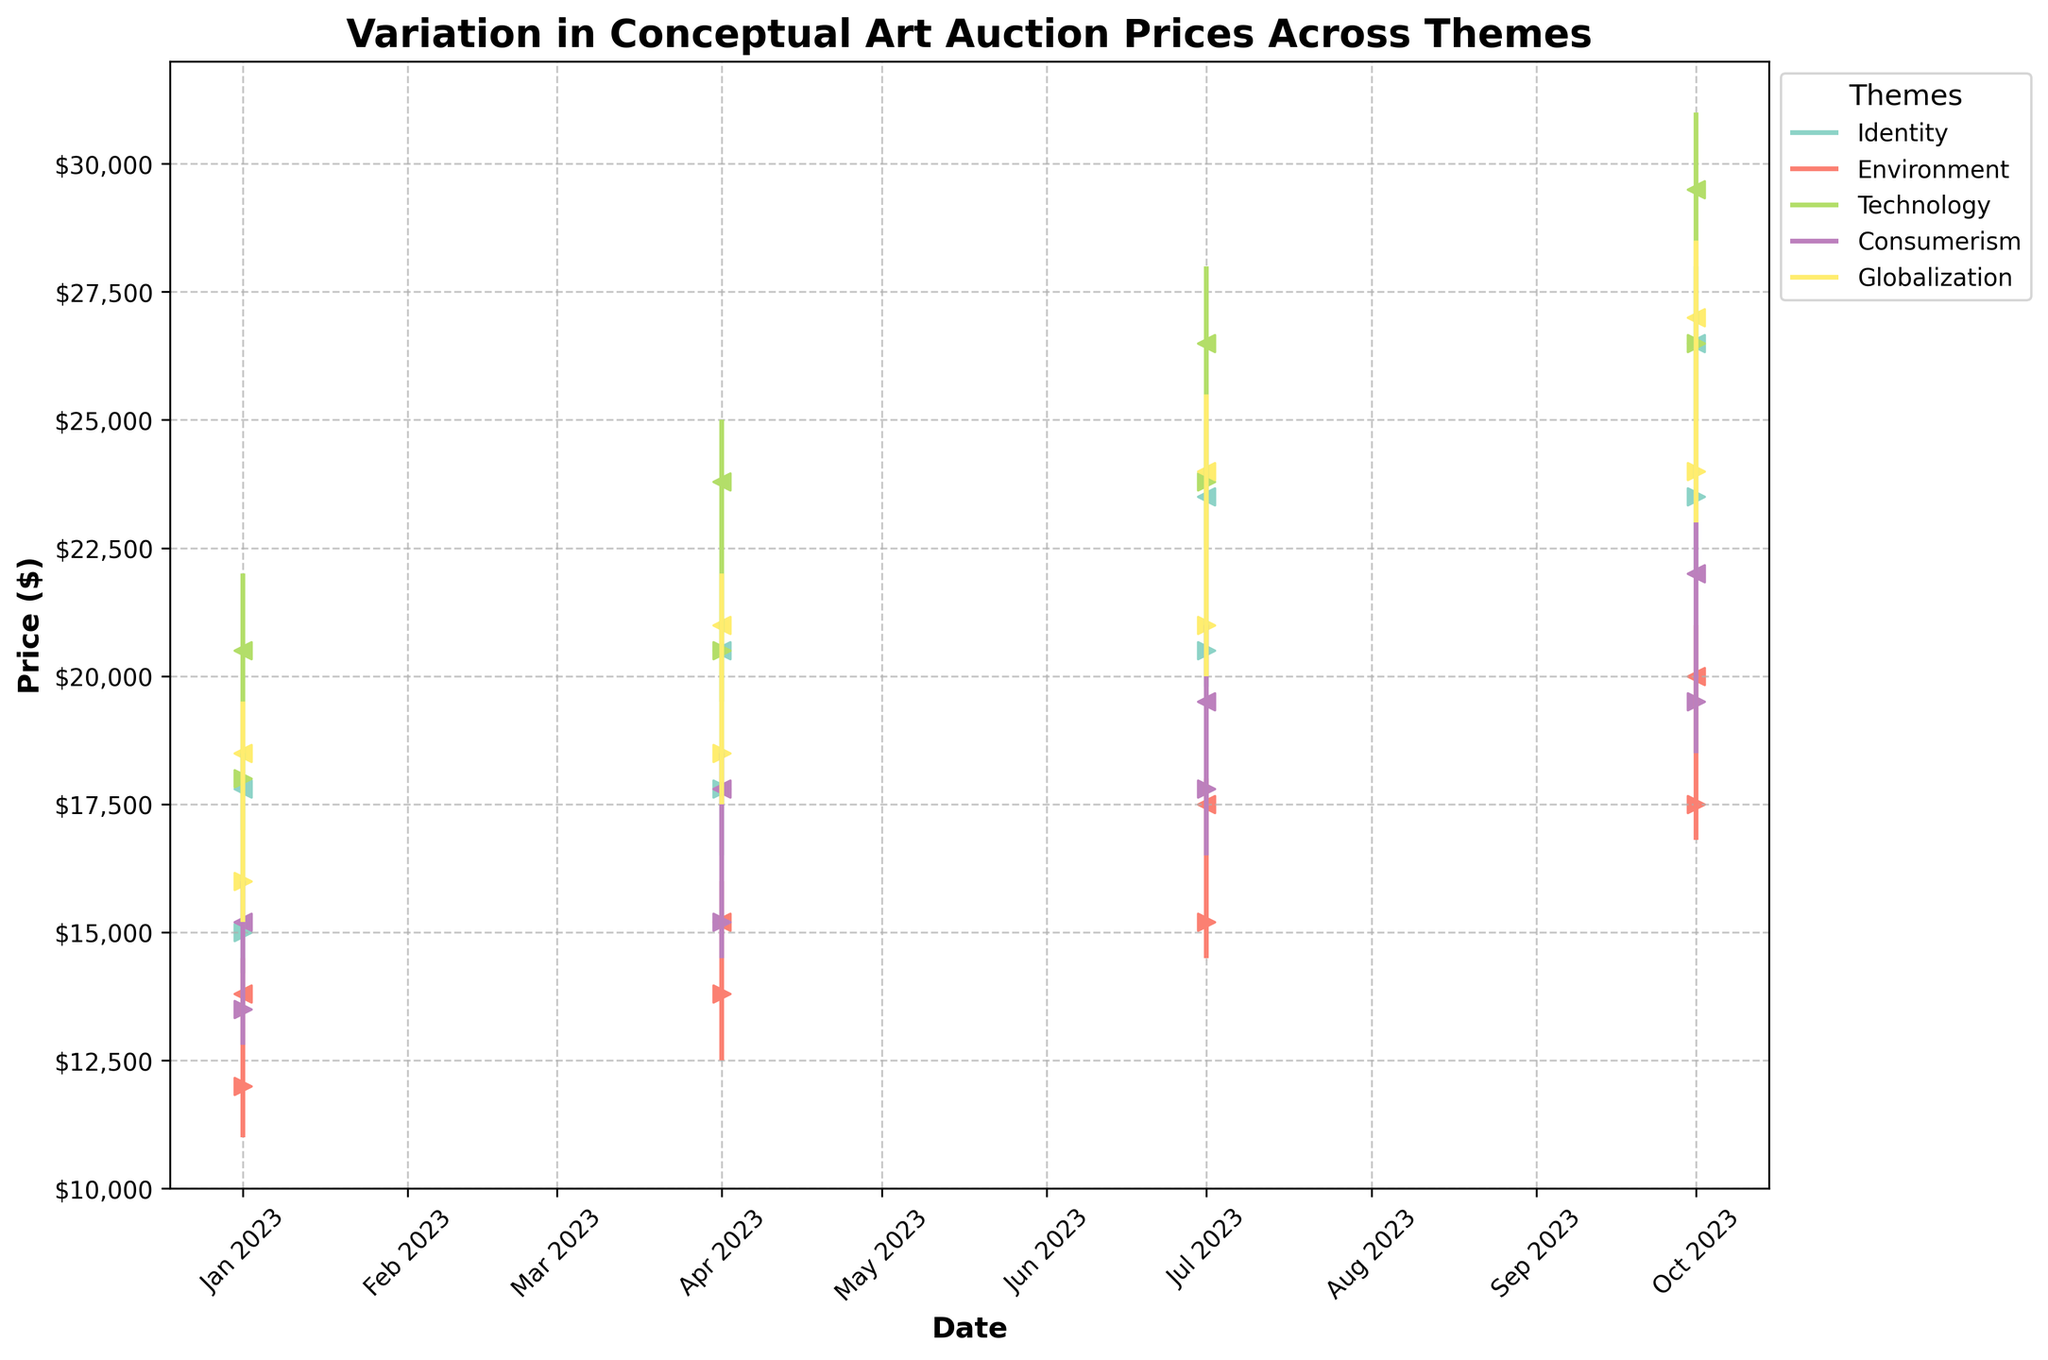What is the title of the plot? The title of the plot is clearly written at the top of the figure, which states "Variation in Conceptual Art Auction Prices Across Themes".
Answer: Variation in Conceptual Art Auction Prices Across Themes Which theme had the highest closing price in October 2023? To find the theme with the highest closing price, look at the closing prices for all themes in October 2023. The highest closing price is $29,500 for the theme 'Technology'.
Answer: Technology What is the overall trend for the "Identity" theme throughout the year? To understand the trend, observe the series of OHLC bars for the "Identity" theme. All prices (open, high, low, close) are consistently increasing from January to October 2023, indicating an upward trend.
Answer: Upward trend How many themes are tracked in this plot? Count the number of distinct themes in the plot's legend. There are five themes listed: 'Identity', 'Environment', 'Technology', 'Consumerism', and 'Globalization'.
Answer: Five By how much did the closing price for "Consumerism" increase from January to October 2023? Find the closing prices for "Consumerism" in January and October 2023. The prices are $15,200 and $22,000, respectively. Subtract the January price from the October price: $22,000 - $15,200 = $6,800.
Answer: $6,800 Which month shows the highest variability in auction prices for "Environment"? The variability can be assessed by looking at the range between the high and low prices. July 2023 for "Environment" shows prices ranging from $14,500 to $18,000, a variability of $3,500, which is the highest among the periods.
Answer: July 2023 Is there a theme that shows a consistent pattern of only increasing closing prices every quarter? Check the closing prices for each theme across the quarters. Both "Identity" and "Technology" show consistent increases in closing prices each quarter from January to October 2023.
Answer: Identity and Technology How does the closing price of "Globalization" in July 2023 compare to "Environment" in the same month? Look at the closing prices for "Globalization" and "Environment" in July 2023. The closing prices are $24,000 and $17,500, respectively. Globalization's closing price is higher.
Answer: Globalization is higher What is the average closing price for the "Technology" theme across all quarters? Add the closing prices for "Technology" in each quarter ($20,500, $23,800, $26,500, and $29,500), then divide by 4. The sum is $100,300, and the average is $25,075.
Answer: $25,075 